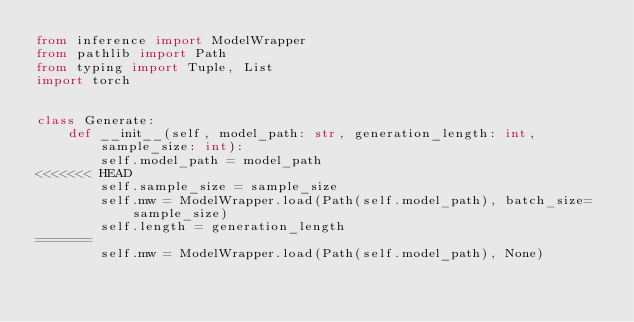Convert code to text. <code><loc_0><loc_0><loc_500><loc_500><_Python_>from inference import ModelWrapper
from pathlib import Path
from typing import Tuple, List
import torch


class Generate:
    def __init__(self, model_path: str, generation_length: int, sample_size: int):
        self.model_path = model_path
<<<<<<< HEAD
        self.sample_size = sample_size
        self.mw = ModelWrapper.load(Path(self.model_path), batch_size=sample_size)
        self.length = generation_length
=======
        self.mw = ModelWrapper.load(Path(self.model_path), None)</code> 